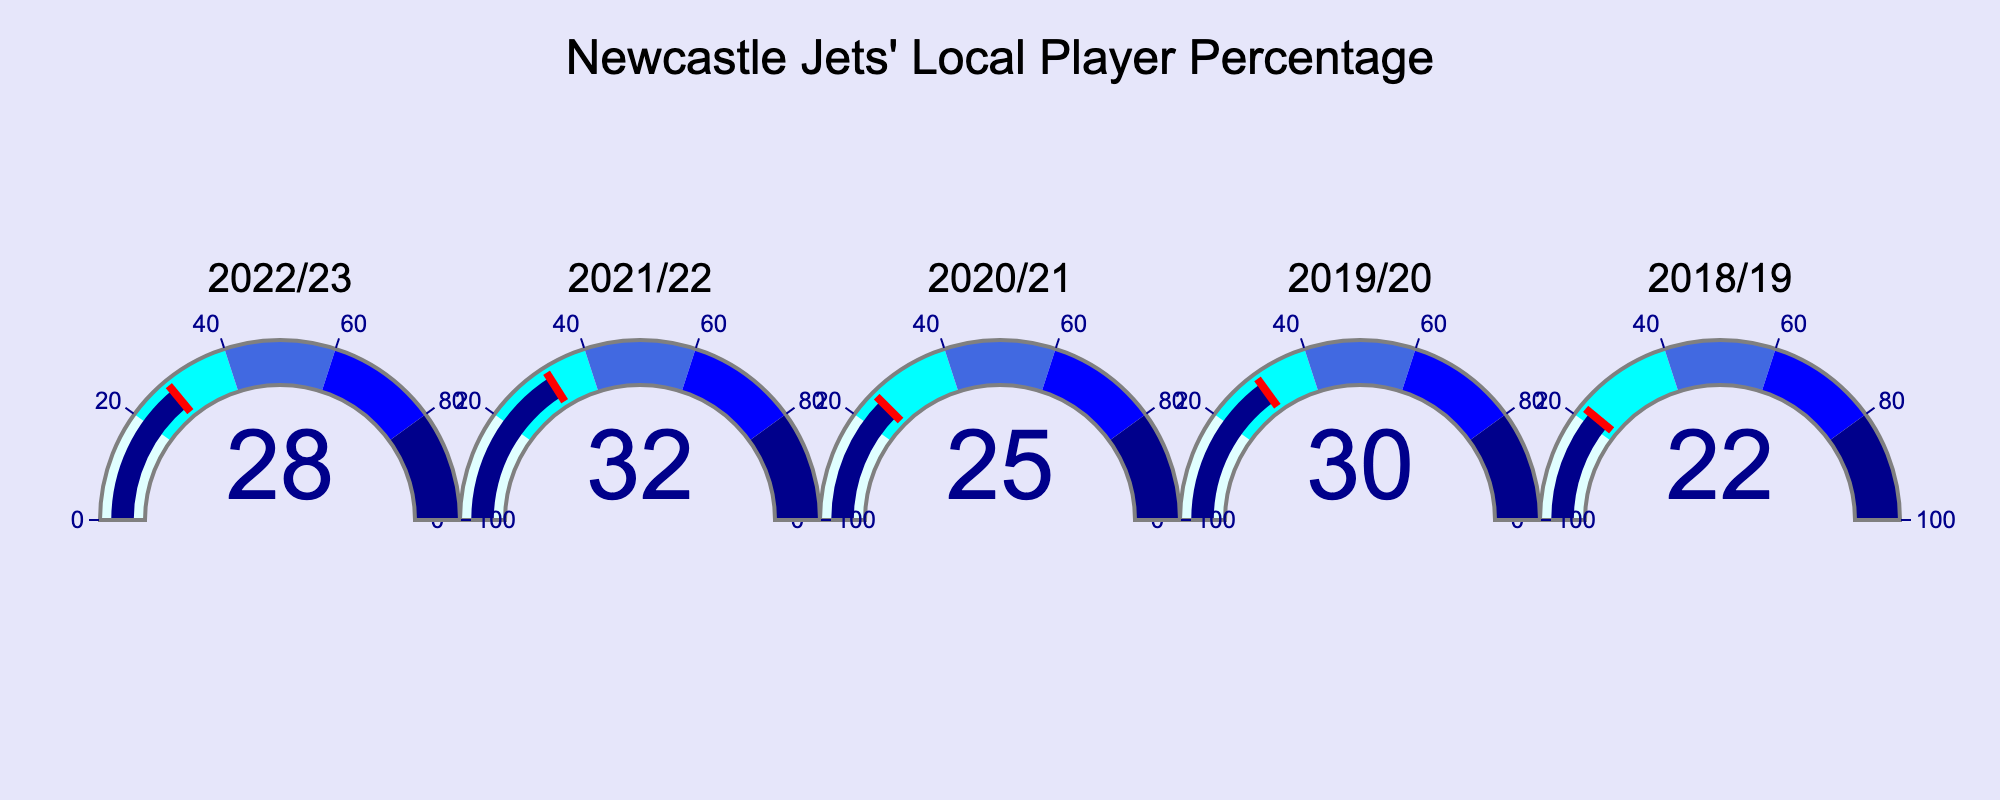how many seasons are displayed in the figure? There are five gauge charts displayed, each representing a different season. Counting these seasons gives us the total number of seasons displayed.
Answer: 5 what is the title of the figure? The title of the figure is displayed at the top and reads, "Newcastle Jets' Local Player Percentage".
Answer: Newcastle Jets' Local Player Percentage which season has the highest percentage of local players? By observing the values on each gauge chart, the season with the highest percentage of local players is 2021/22 with 32%.
Answer: 2021/22 which season has the lowest percentage of local players? By observing the values on each gauge chart, the season with the lowest percentage of local players is 2018/19 with 22%.
Answer: 2018/19 what is the average percentage of local players over the displayed seasons? Add the percentages from each of the five seasons ((28 + 32 + 25 + 30 + 22) = 137) and then divide by the number of seasons (5). The average percentage is 137/5 = 27.4.
Answer: 27.4 by how much did the percentage of local players increase or decrease from the 2019/20 season to the 2020/21 season? The percentage in 2019/20 was 30 and in 2020/21 was 25. Subtracting these gives the difference (25 - 30 = -5), so it decreased by 5%.
Answer: -5 is the percentage of local players in the 2022/23 season above or below the average of the displayed seasons? The percentage in the 2022/23 season is 28. Comparing this to the average of 27.4, 28 is above the average.
Answer: above how many seasons have a local player percentage above 25? Seasons with percentages above 25 are 2022/23 (28), 2021/22 (32), 2019/20 (30), and 2018/19 (22). Four out of these have a percentage above 25.
Answer: 4 